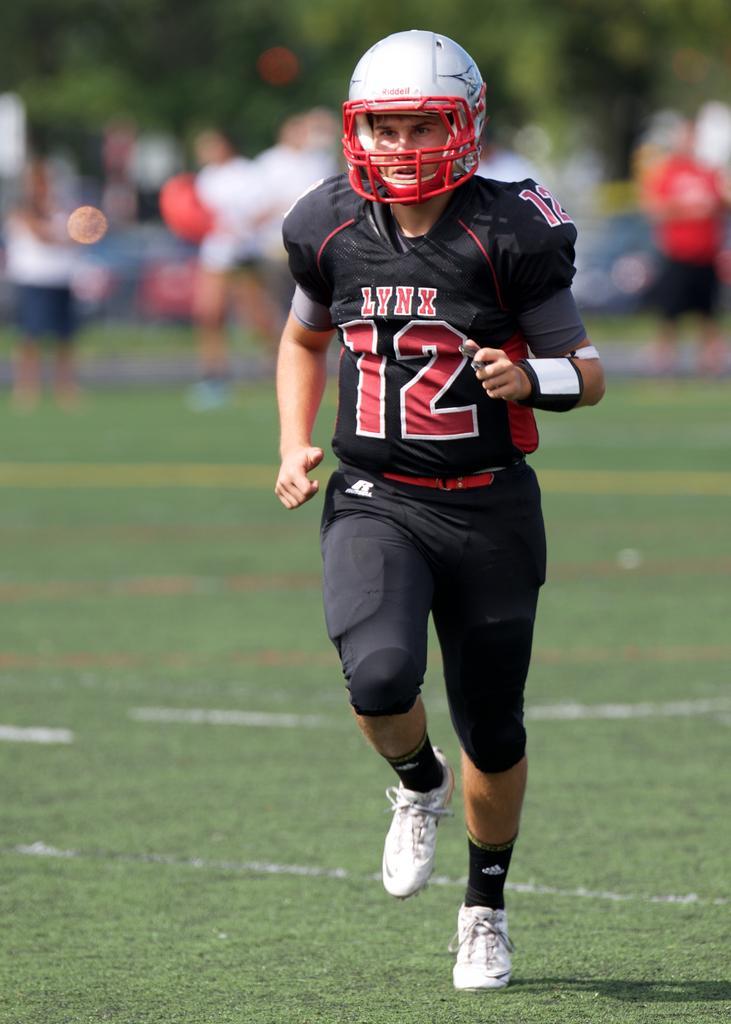Please provide a concise description of this image. In this picture I can see a person with sports jersey and helmet. I can see green grass. 